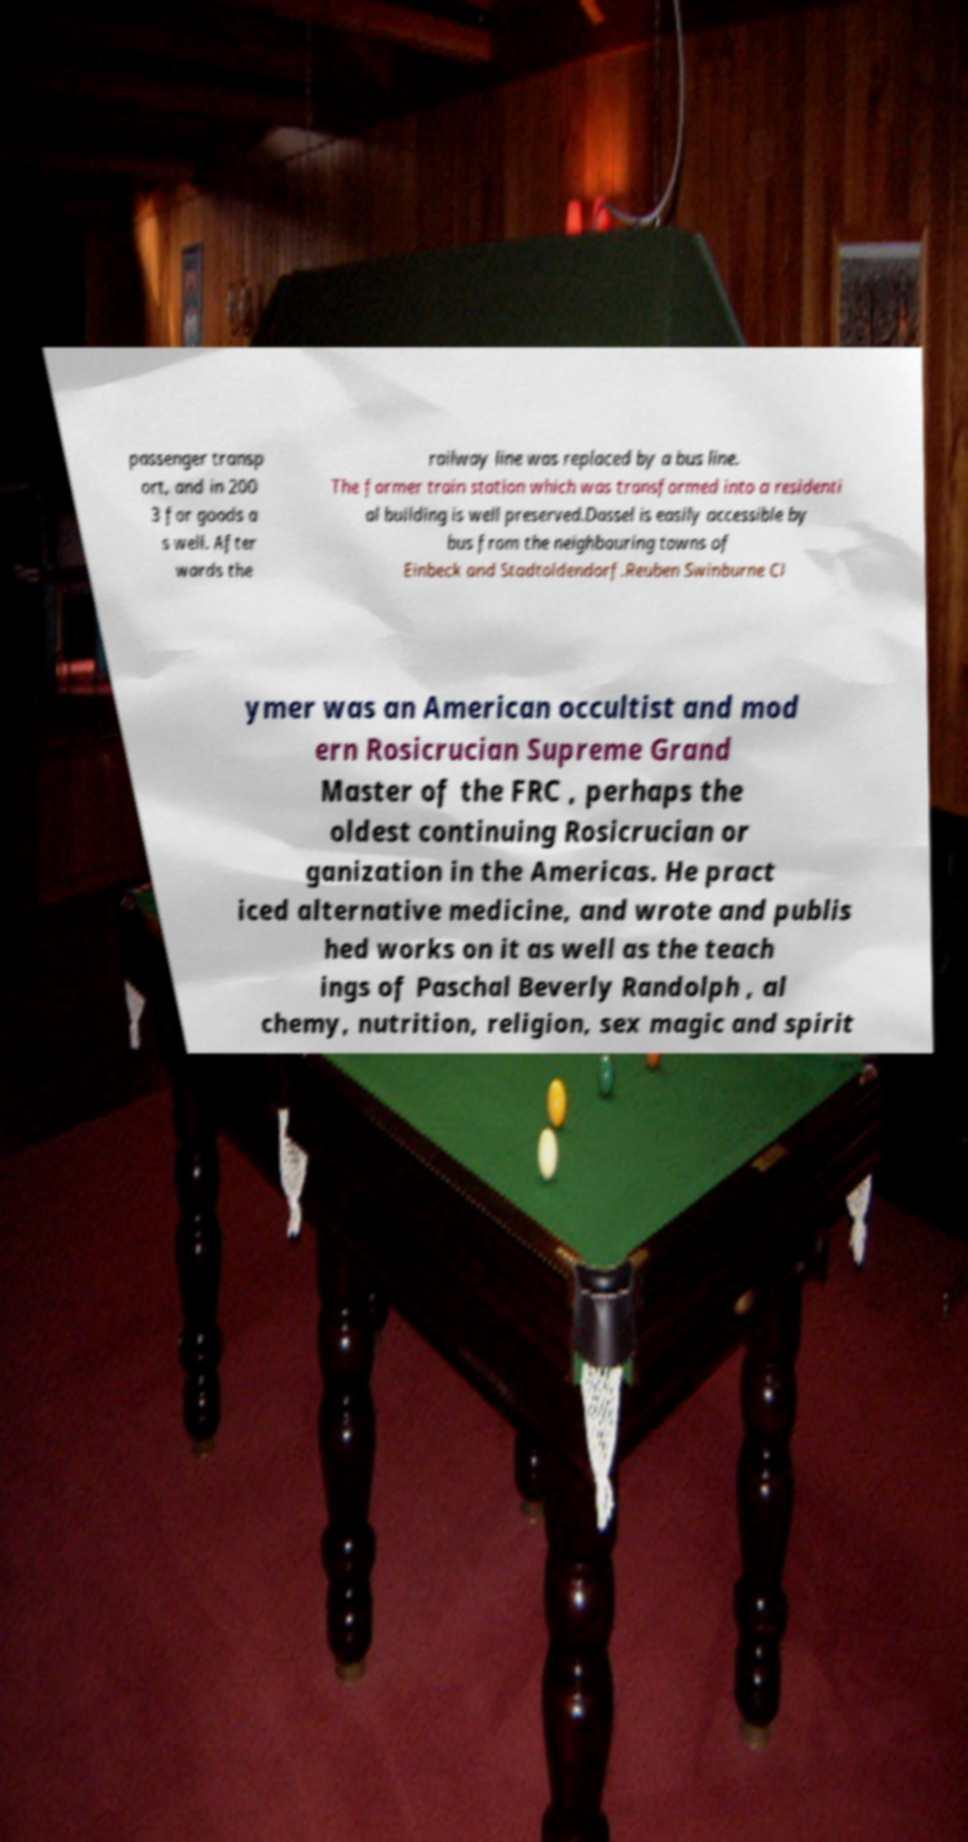There's text embedded in this image that I need extracted. Can you transcribe it verbatim? passenger transp ort, and in 200 3 for goods a s well. After wards the railway line was replaced by a bus line. The former train station which was transformed into a residenti al building is well preserved.Dassel is easily accessible by bus from the neighbouring towns of Einbeck and Stadtoldendorf.Reuben Swinburne Cl ymer was an American occultist and mod ern Rosicrucian Supreme Grand Master of the FRC , perhaps the oldest continuing Rosicrucian or ganization in the Americas. He pract iced alternative medicine, and wrote and publis hed works on it as well as the teach ings of Paschal Beverly Randolph , al chemy, nutrition, religion, sex magic and spirit 